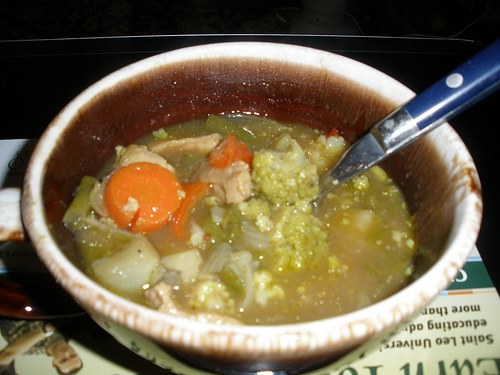If this soup were to become part of a fictional storyline in a novel, what role would it play? In a novel, this soup could play the role of a poignant detail that brings characters together. It might be a grandmother’s secret recipe passed down through generations, symbolizing love, family heritage, and the comfort of home. During a difficult time, a character might find solace and a sense of connection by recreating this soup, bringing back memories of loved ones and forgotten times, ultimately leading to moments of healing and reconciliation. 